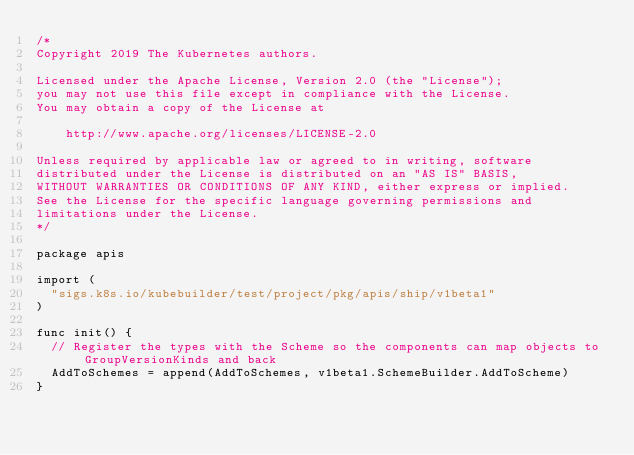<code> <loc_0><loc_0><loc_500><loc_500><_Go_>/*
Copyright 2019 The Kubernetes authors.

Licensed under the Apache License, Version 2.0 (the "License");
you may not use this file except in compliance with the License.
You may obtain a copy of the License at

    http://www.apache.org/licenses/LICENSE-2.0

Unless required by applicable law or agreed to in writing, software
distributed under the License is distributed on an "AS IS" BASIS,
WITHOUT WARRANTIES OR CONDITIONS OF ANY KIND, either express or implied.
See the License for the specific language governing permissions and
limitations under the License.
*/

package apis

import (
	"sigs.k8s.io/kubebuilder/test/project/pkg/apis/ship/v1beta1"
)

func init() {
	// Register the types with the Scheme so the components can map objects to GroupVersionKinds and back
	AddToSchemes = append(AddToSchemes, v1beta1.SchemeBuilder.AddToScheme)
}
</code> 